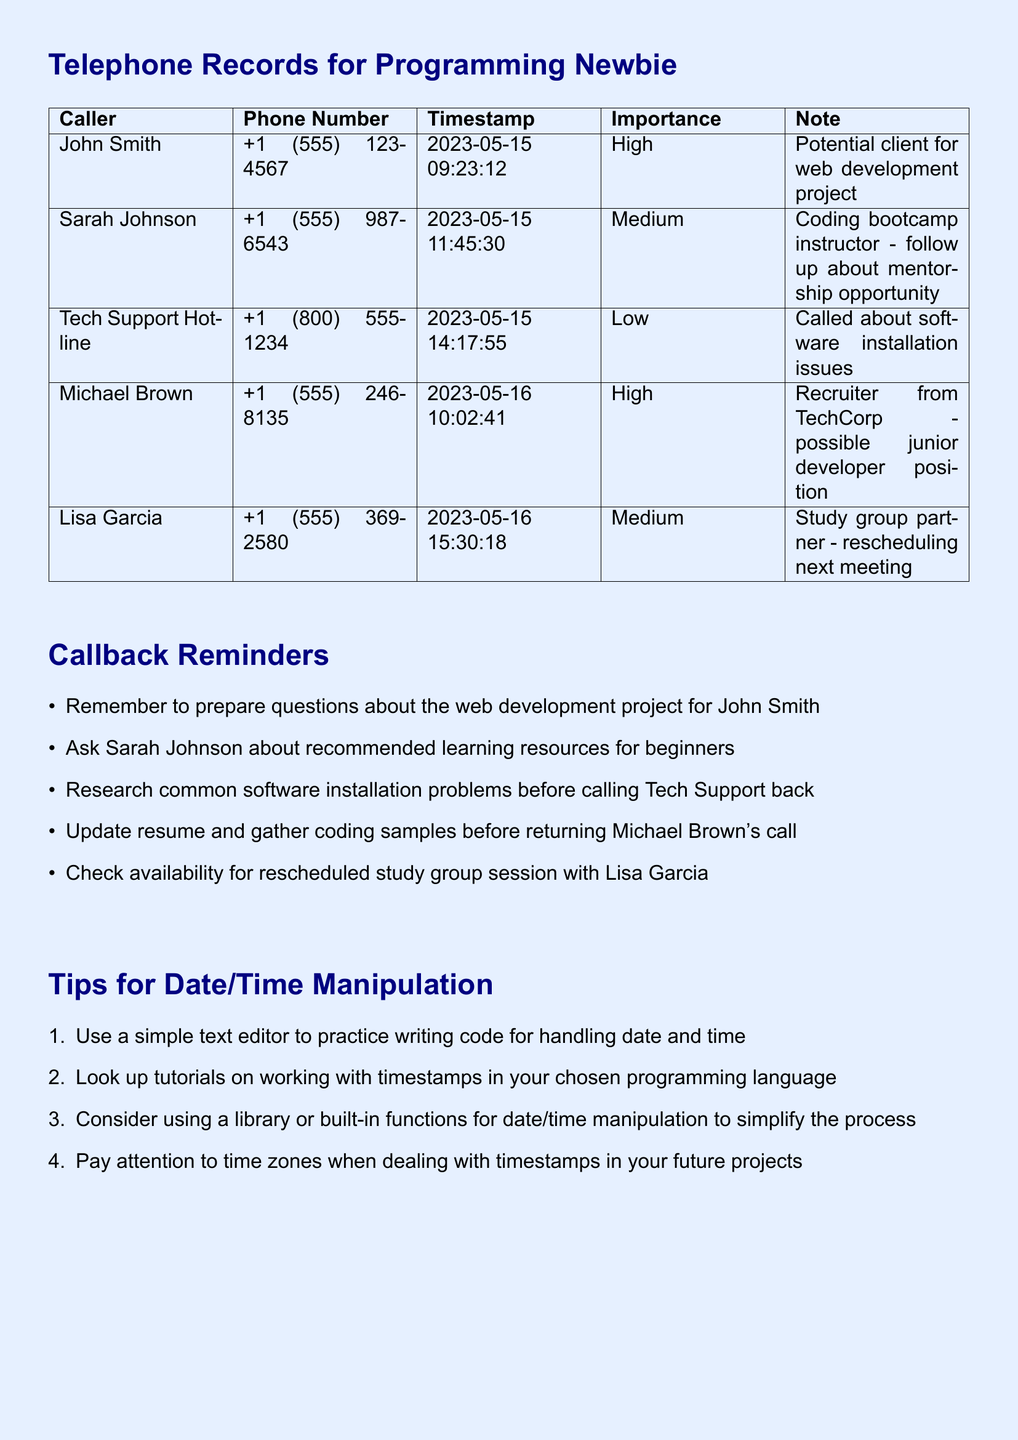What is the importance level of John Smith's call? The importance level is specified in the document, which states John Smith's call is marked as "High."
Answer: High What is the timestamp of Michael Brown's call? The timestamp for Michael Brown's call can be found in the records and reads "2023-05-16 10:02:41."
Answer: 2023-05-16 10:02:41 Who is the caller with the lowest importance? The caller with the lowest importance level is identified in the table as "Tech Support Hotline" with a "Low" rating.
Answer: Tech Support Hotline How many contacts are listed with a "Medium" importance level? Counting the entries in the document, there are two contacts with a "Medium" importance level.
Answer: 2 What advice is given for date/time manipulation? The document provides several pieces of advice, one being "Use a simple text editor to practice writing code for handling date and time."
Answer: Use a simple text editor What kind of opportunity is mentioned for Sarah Johnson? The mention of Sarah Johnson includes a coding bootcamp instructor role, particularly a follow-up about "mentorship opportunity."
Answer: Mentorship opportunity Which contact is associated with a potential junior developer position? The contact associated with this opportunity is characterized in the records as "Michael Brown."
Answer: Michael Brown What is the purpose of the Callback Reminders section? The purpose is to provide reminders for follow-up actions based on the missed calls listed in the record.
Answer: Follow-up actions 